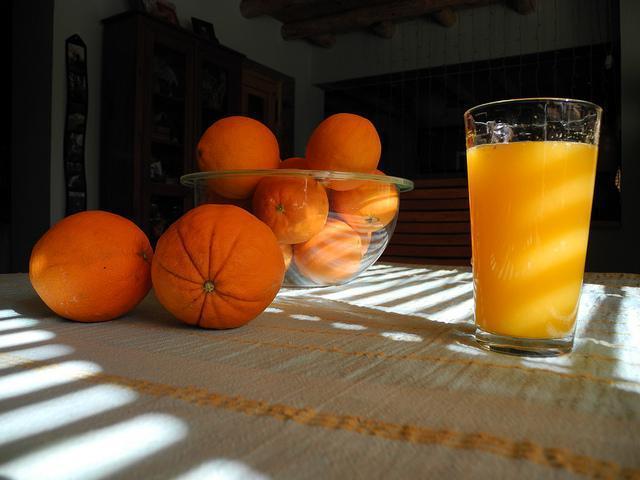How many oranges that are not in the bowl?
Give a very brief answer. 2. How many oranges can you see?
Give a very brief answer. 6. 